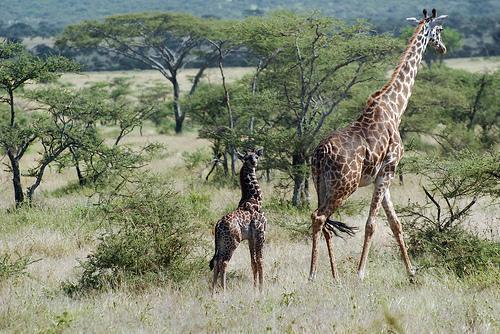How many animals do you see?
Give a very brief answer. 2. 